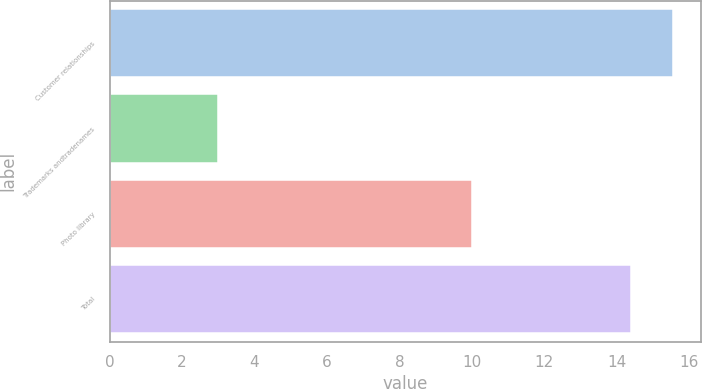Convert chart to OTSL. <chart><loc_0><loc_0><loc_500><loc_500><bar_chart><fcel>Customer relationships<fcel>Trademarks andtradenames<fcel>Photo library<fcel>Total<nl><fcel>15.56<fcel>3<fcel>10<fcel>14.4<nl></chart> 